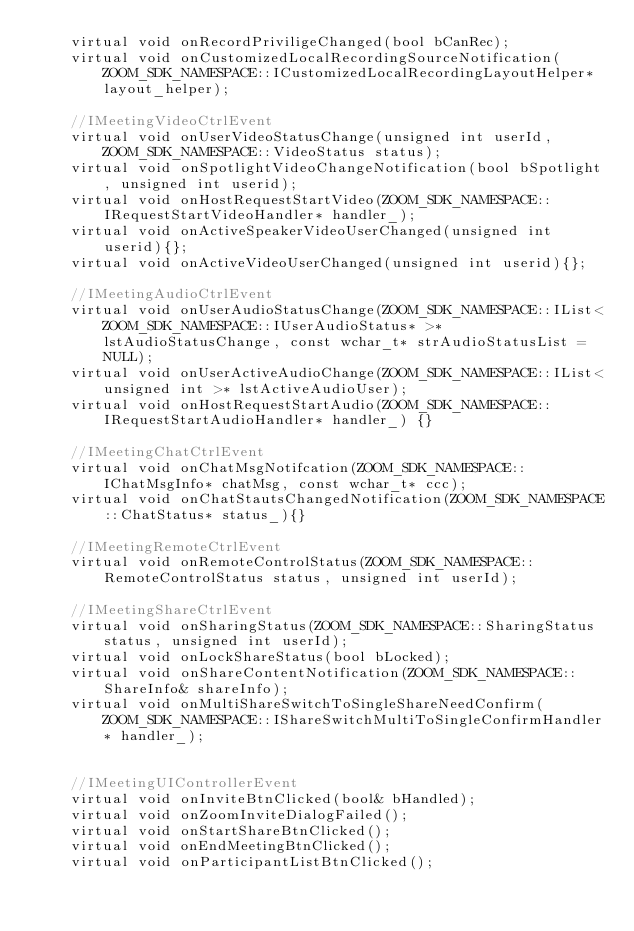<code> <loc_0><loc_0><loc_500><loc_500><_C_>	virtual void onRecordPriviligeChanged(bool bCanRec);
	virtual void onCustomizedLocalRecordingSourceNotification(ZOOM_SDK_NAMESPACE::ICustomizedLocalRecordingLayoutHelper* layout_helper);

	//IMeetingVideoCtrlEvent
	virtual void onUserVideoStatusChange(unsigned int userId, ZOOM_SDK_NAMESPACE::VideoStatus status);
	virtual void onSpotlightVideoChangeNotification(bool bSpotlight, unsigned int userid);
	virtual void onHostRequestStartVideo(ZOOM_SDK_NAMESPACE::IRequestStartVideoHandler* handler_);
	virtual void onActiveSpeakerVideoUserChanged(unsigned int userid){};
	virtual void onActiveVideoUserChanged(unsigned int userid){};

	//IMeetingAudioCtrlEvent
	virtual void onUserAudioStatusChange(ZOOM_SDK_NAMESPACE::IList<ZOOM_SDK_NAMESPACE::IUserAudioStatus* >* lstAudioStatusChange, const wchar_t* strAudioStatusList = NULL);
	virtual void onUserActiveAudioChange(ZOOM_SDK_NAMESPACE::IList<unsigned int >* lstActiveAudioUser);
	virtual void onHostRequestStartAudio(ZOOM_SDK_NAMESPACE::IRequestStartAudioHandler* handler_) {}

	//IMeetingChatCtrlEvent
	virtual void onChatMsgNotifcation(ZOOM_SDK_NAMESPACE::IChatMsgInfo* chatMsg, const wchar_t* ccc);
	virtual void onChatStautsChangedNotification(ZOOM_SDK_NAMESPACE::ChatStatus* status_){}

	//IMeetingRemoteCtrlEvent
	virtual void onRemoteControlStatus(ZOOM_SDK_NAMESPACE::RemoteControlStatus status, unsigned int userId);

	//IMeetingShareCtrlEvent
	virtual void onSharingStatus(ZOOM_SDK_NAMESPACE::SharingStatus status, unsigned int userId);
	virtual void onLockShareStatus(bool bLocked);
	virtual void onShareContentNotification(ZOOM_SDK_NAMESPACE::ShareInfo& shareInfo);
	virtual void onMultiShareSwitchToSingleShareNeedConfirm(ZOOM_SDK_NAMESPACE::IShareSwitchMultiToSingleConfirmHandler* handler_);


	//IMeetingUIControllerEvent
	virtual void onInviteBtnClicked(bool& bHandled);
	virtual void onZoomInviteDialogFailed();
	virtual void onStartShareBtnClicked();
	virtual void onEndMeetingBtnClicked();
	virtual void onParticipantListBtnClicked();</code> 